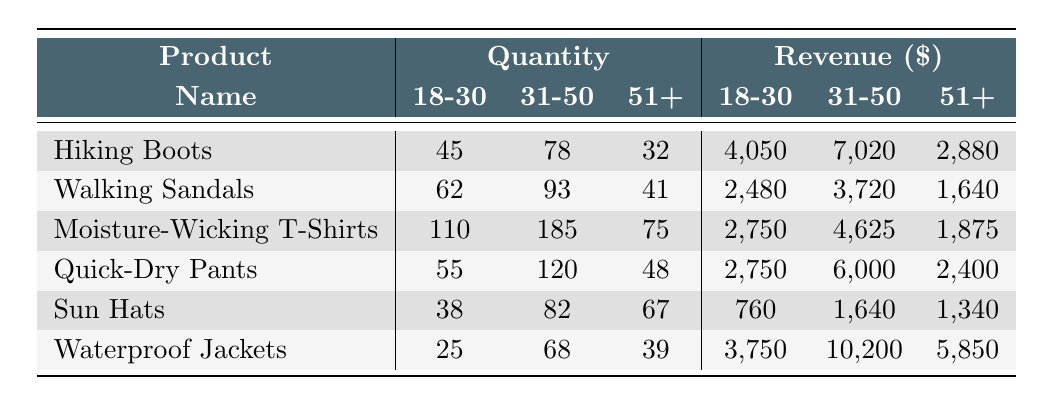What is the total quantity of Hiking Boots sold to the 31-50 age group? The table shows that 78 Hiking Boots were sold to the 31-50 age group.
Answer: 78 How much revenue was generated from Walking Sandals for the 51+ age group? The revenue for Walking Sandals sold to the 51+ age group is listed as 1,640 dollars in the table.
Answer: 1,640 What is the average quantity sold for Moisture-Wicking T-Shirts across all age groups? The quantities sold are 110, 185, and 75. Adding them gives 110 + 185 + 75 = 370. The average is then 370 / 3 = 123.33.
Answer: 123.33 Which product generated the highest revenue from the 31-50 age group? By comparing revenues for the 31-50 age group, Hiking Boots (7,020), Walking Sandals (3,720), Moisture-Wicking T-Shirts (4,625), Quick-Dry Pants (6,000), Sun Hats (1,640), and Waterproof Jackets (10,200), we find that Waterproof Jackets brought in the most with 10,200 dollars.
Answer: Waterproof Jackets Did the 18-30 age group buy more Quick-Dry Pants or Moisture-Wicking T-Shirts? The table shows 55 Quick-Dry Pants sold and 110 Moisture-Wicking T-Shirts sold to the 18-30 age group. Since 110 is greater than 55, the 18-30 age group bought more Moisture-Wicking T-Shirts.
Answer: Yes What is the total revenue from Waterproof Jackets across all age groups? The revenues for Waterproof Jackets are 3,750, 10,200, and 5,850. Adding these amounts gives 3,750 + 10,200 + 5,850 = 19,800 dollars.
Answer: 19,800 Which product sold the least quantity to the 51+ age group? The quantities for the 51+ age group are Hiking Boots (32), Walking Sandals (41), Moisture-Wicking T-Shirts (75), Quick-Dry Pants (48), Sun Hats (67), and Waterproof Jackets (39). The Hiking Boots sold the least with 32 units.
Answer: Hiking Boots What is the difference in revenue between the highest and lowest-grossing products for the 18-30 age group? For the 18-30 age group, revenue for Hiking Boots is 4,050, for Walking Sandals is 2,480, for Moisture-Wicking T-Shirts is 2,750, for Quick-Dry Pants is 2,750, for Sun Hats is 760, and for Waterproof Jackets is 3,750. The highest is Hiking Boots (4,050) and the lowest is Sun Hats (760), giving a difference of 4,050 - 760 = 3,290 dollars.
Answer: 3,290 Which age group spent the least on Sun Hats? The revenues for Sun Hats by age group are 760 (18-30), 1,640 (31-50), and 1,340 (51+). The least revenue, which corresponds to the least spending, comes from the 18-30 age group.
Answer: 18-30 What percentage of the total quantity sold of Walking Sandals was purchased by the 31-50 age group? The total quantity of Walking Sandals sold is 62 + 93 + 41 = 196. The quantity bought by the 31-50 age group is 93. The percentage is calculated as (93 / 196) * 100 = approximately 47.43%.
Answer: 47.43% 